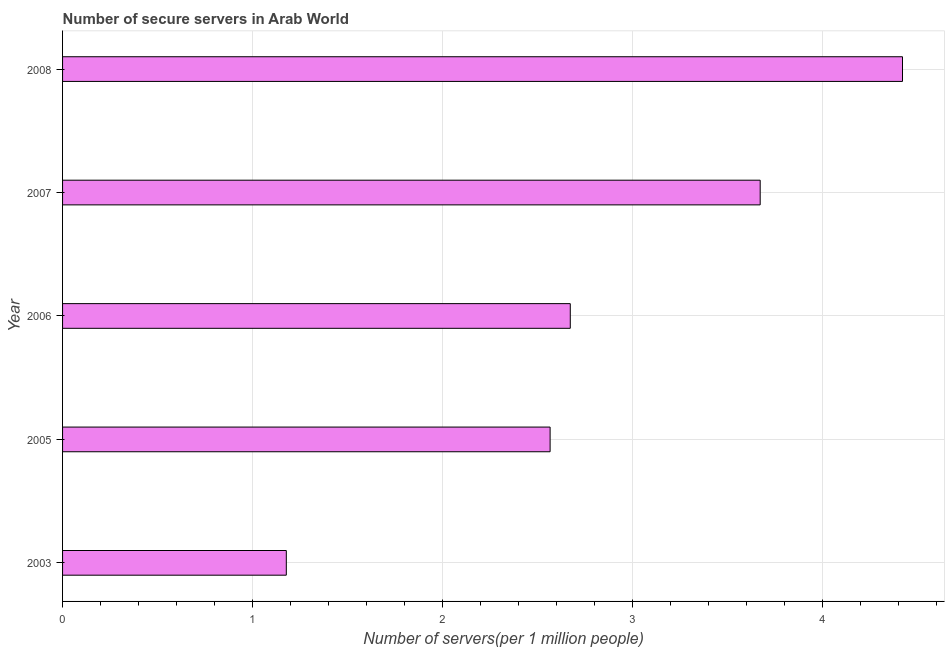What is the title of the graph?
Provide a short and direct response. Number of secure servers in Arab World. What is the label or title of the X-axis?
Your response must be concise. Number of servers(per 1 million people). What is the number of secure internet servers in 2008?
Your answer should be very brief. 4.42. Across all years, what is the maximum number of secure internet servers?
Make the answer very short. 4.42. Across all years, what is the minimum number of secure internet servers?
Provide a short and direct response. 1.18. In which year was the number of secure internet servers maximum?
Your answer should be compact. 2008. In which year was the number of secure internet servers minimum?
Offer a very short reply. 2003. What is the sum of the number of secure internet servers?
Ensure brevity in your answer.  14.51. What is the difference between the number of secure internet servers in 2003 and 2008?
Offer a terse response. -3.24. What is the average number of secure internet servers per year?
Make the answer very short. 2.9. What is the median number of secure internet servers?
Your answer should be compact. 2.67. In how many years, is the number of secure internet servers greater than 3.6 ?
Provide a short and direct response. 2. What is the ratio of the number of secure internet servers in 2006 to that in 2008?
Offer a very short reply. 0.6. Is the difference between the number of secure internet servers in 2003 and 2005 greater than the difference between any two years?
Provide a succinct answer. No. What is the difference between the highest and the second highest number of secure internet servers?
Your response must be concise. 0.75. What is the difference between the highest and the lowest number of secure internet servers?
Your answer should be compact. 3.24. How many years are there in the graph?
Provide a succinct answer. 5. What is the difference between two consecutive major ticks on the X-axis?
Offer a very short reply. 1. Are the values on the major ticks of X-axis written in scientific E-notation?
Your answer should be very brief. No. What is the Number of servers(per 1 million people) in 2003?
Keep it short and to the point. 1.18. What is the Number of servers(per 1 million people) in 2005?
Offer a very short reply. 2.57. What is the Number of servers(per 1 million people) of 2006?
Offer a terse response. 2.67. What is the Number of servers(per 1 million people) in 2007?
Offer a very short reply. 3.67. What is the Number of servers(per 1 million people) of 2008?
Provide a succinct answer. 4.42. What is the difference between the Number of servers(per 1 million people) in 2003 and 2005?
Your answer should be compact. -1.39. What is the difference between the Number of servers(per 1 million people) in 2003 and 2006?
Provide a short and direct response. -1.5. What is the difference between the Number of servers(per 1 million people) in 2003 and 2007?
Provide a succinct answer. -2.49. What is the difference between the Number of servers(per 1 million people) in 2003 and 2008?
Keep it short and to the point. -3.24. What is the difference between the Number of servers(per 1 million people) in 2005 and 2006?
Ensure brevity in your answer.  -0.11. What is the difference between the Number of servers(per 1 million people) in 2005 and 2007?
Offer a terse response. -1.11. What is the difference between the Number of servers(per 1 million people) in 2005 and 2008?
Your response must be concise. -1.86. What is the difference between the Number of servers(per 1 million people) in 2006 and 2007?
Give a very brief answer. -1. What is the difference between the Number of servers(per 1 million people) in 2006 and 2008?
Your answer should be very brief. -1.75. What is the difference between the Number of servers(per 1 million people) in 2007 and 2008?
Offer a very short reply. -0.75. What is the ratio of the Number of servers(per 1 million people) in 2003 to that in 2005?
Provide a succinct answer. 0.46. What is the ratio of the Number of servers(per 1 million people) in 2003 to that in 2006?
Your answer should be very brief. 0.44. What is the ratio of the Number of servers(per 1 million people) in 2003 to that in 2007?
Offer a terse response. 0.32. What is the ratio of the Number of servers(per 1 million people) in 2003 to that in 2008?
Offer a very short reply. 0.27. What is the ratio of the Number of servers(per 1 million people) in 2005 to that in 2006?
Offer a very short reply. 0.96. What is the ratio of the Number of servers(per 1 million people) in 2005 to that in 2007?
Offer a terse response. 0.7. What is the ratio of the Number of servers(per 1 million people) in 2005 to that in 2008?
Your answer should be very brief. 0.58. What is the ratio of the Number of servers(per 1 million people) in 2006 to that in 2007?
Your response must be concise. 0.73. What is the ratio of the Number of servers(per 1 million people) in 2006 to that in 2008?
Give a very brief answer. 0.6. What is the ratio of the Number of servers(per 1 million people) in 2007 to that in 2008?
Provide a short and direct response. 0.83. 